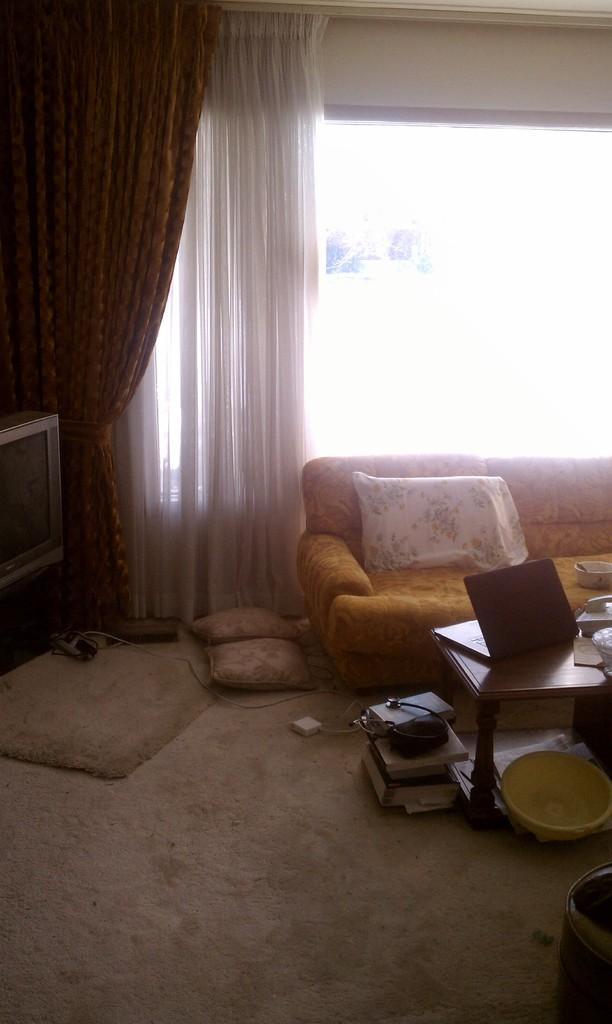What type of furniture is present in the image? There is a sofa in the image. What is placed on the sofa? There is a pillow on the sofa. What type of window treatment is visible in the image? There are curtains in the image. What type of electronic device is present in the image? There is a television in the image. What type of computer is present in the image? There is a laptop on a table in the image. How many bikes are parked in the wilderness in the image? There are no bikes or wilderness present in the image. What type of tin is used to cover the laptop in the image? There is no tin present in the image; the laptop is on a table. 